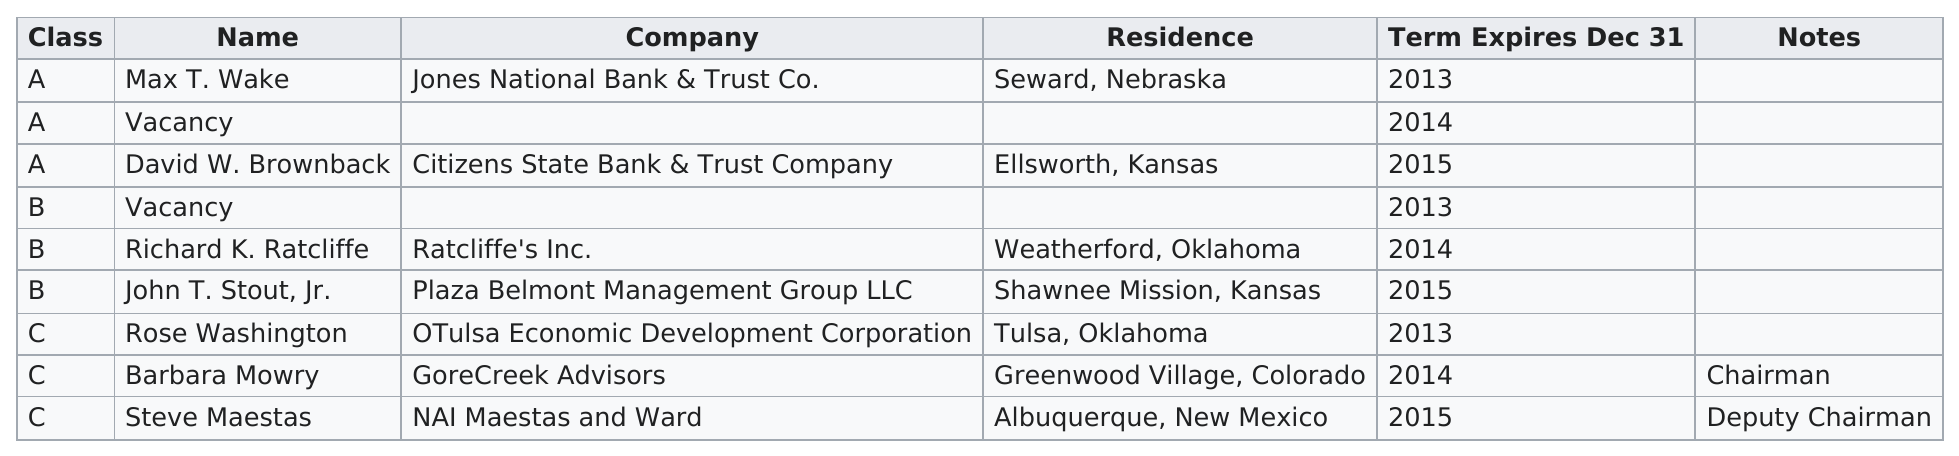Specify some key components in this picture. Barbara Mowry or Rose Washington served as the Chairman of the Board of Directors as of 2013. Jones National Bank & Trust Co. is the company that is at the top of the chart. The total number of different classes is 3. The classes that had the least number of people on their board of directors were A and B. Steve Maestas served as a representative of Nai Maestas and Ward on the Board of Directors, and he also held the position of Deputy Chairman on the Board of Directors. 